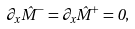<formula> <loc_0><loc_0><loc_500><loc_500>\partial _ { x } \hat { M } ^ { - } = \partial _ { x } \hat { M } ^ { + } = 0 ,</formula> 